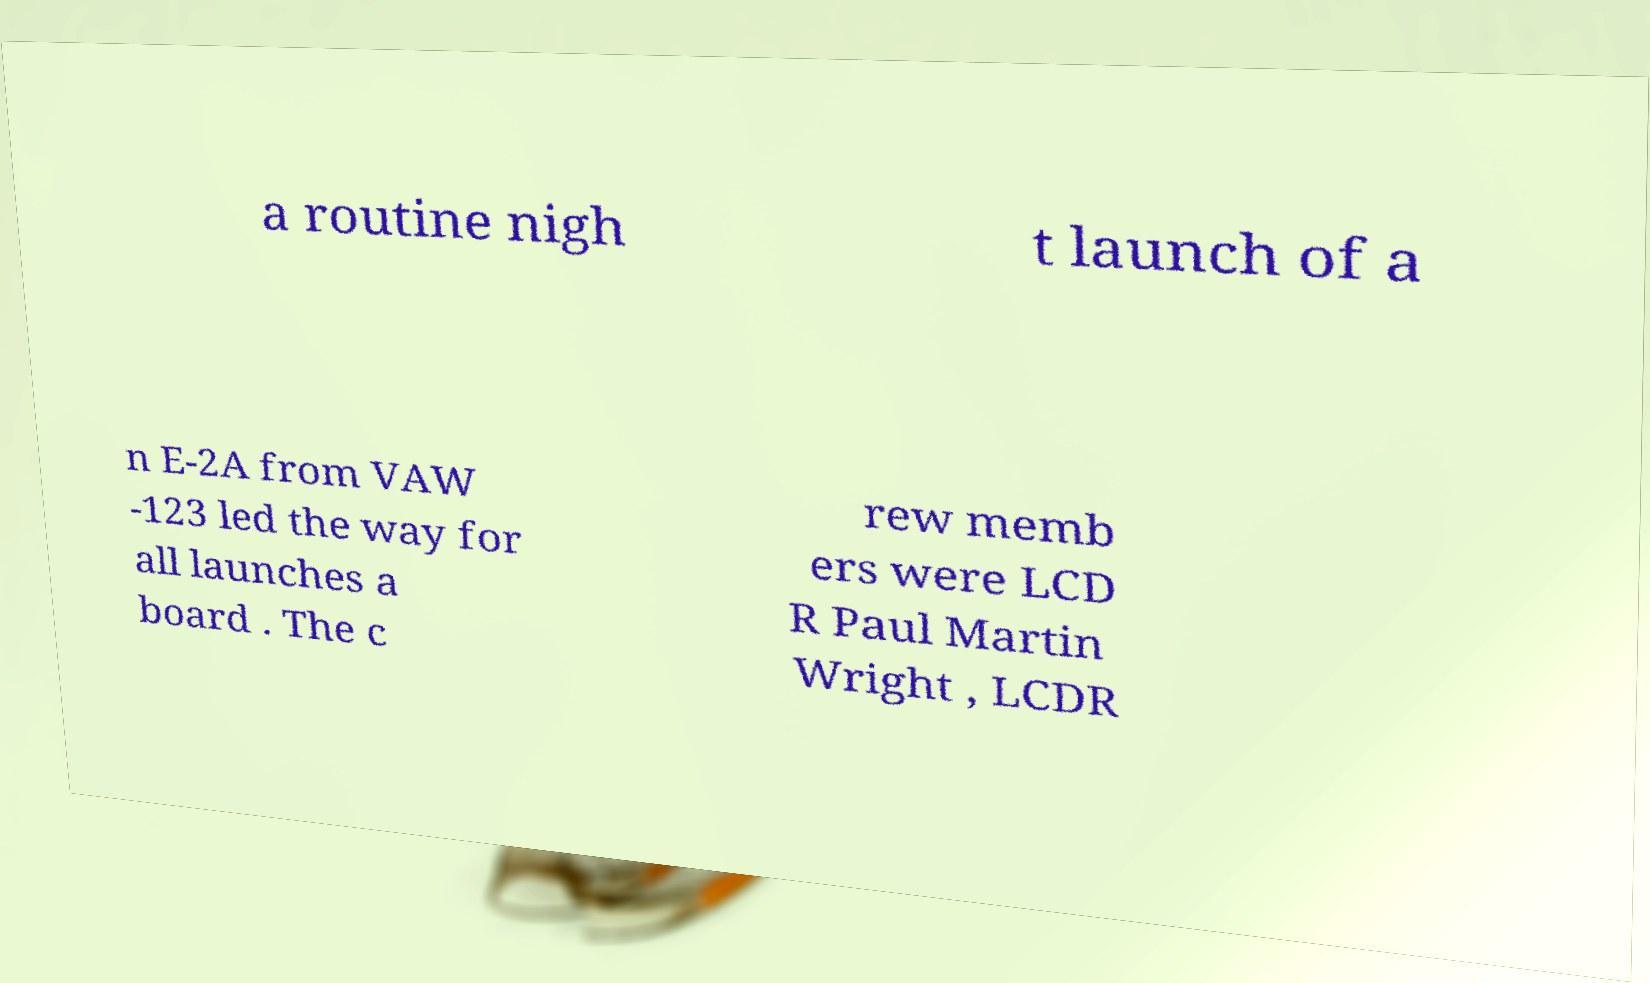I need the written content from this picture converted into text. Can you do that? a routine nigh t launch of a n E-2A from VAW -123 led the way for all launches a board . The c rew memb ers were LCD R Paul Martin Wright , LCDR 